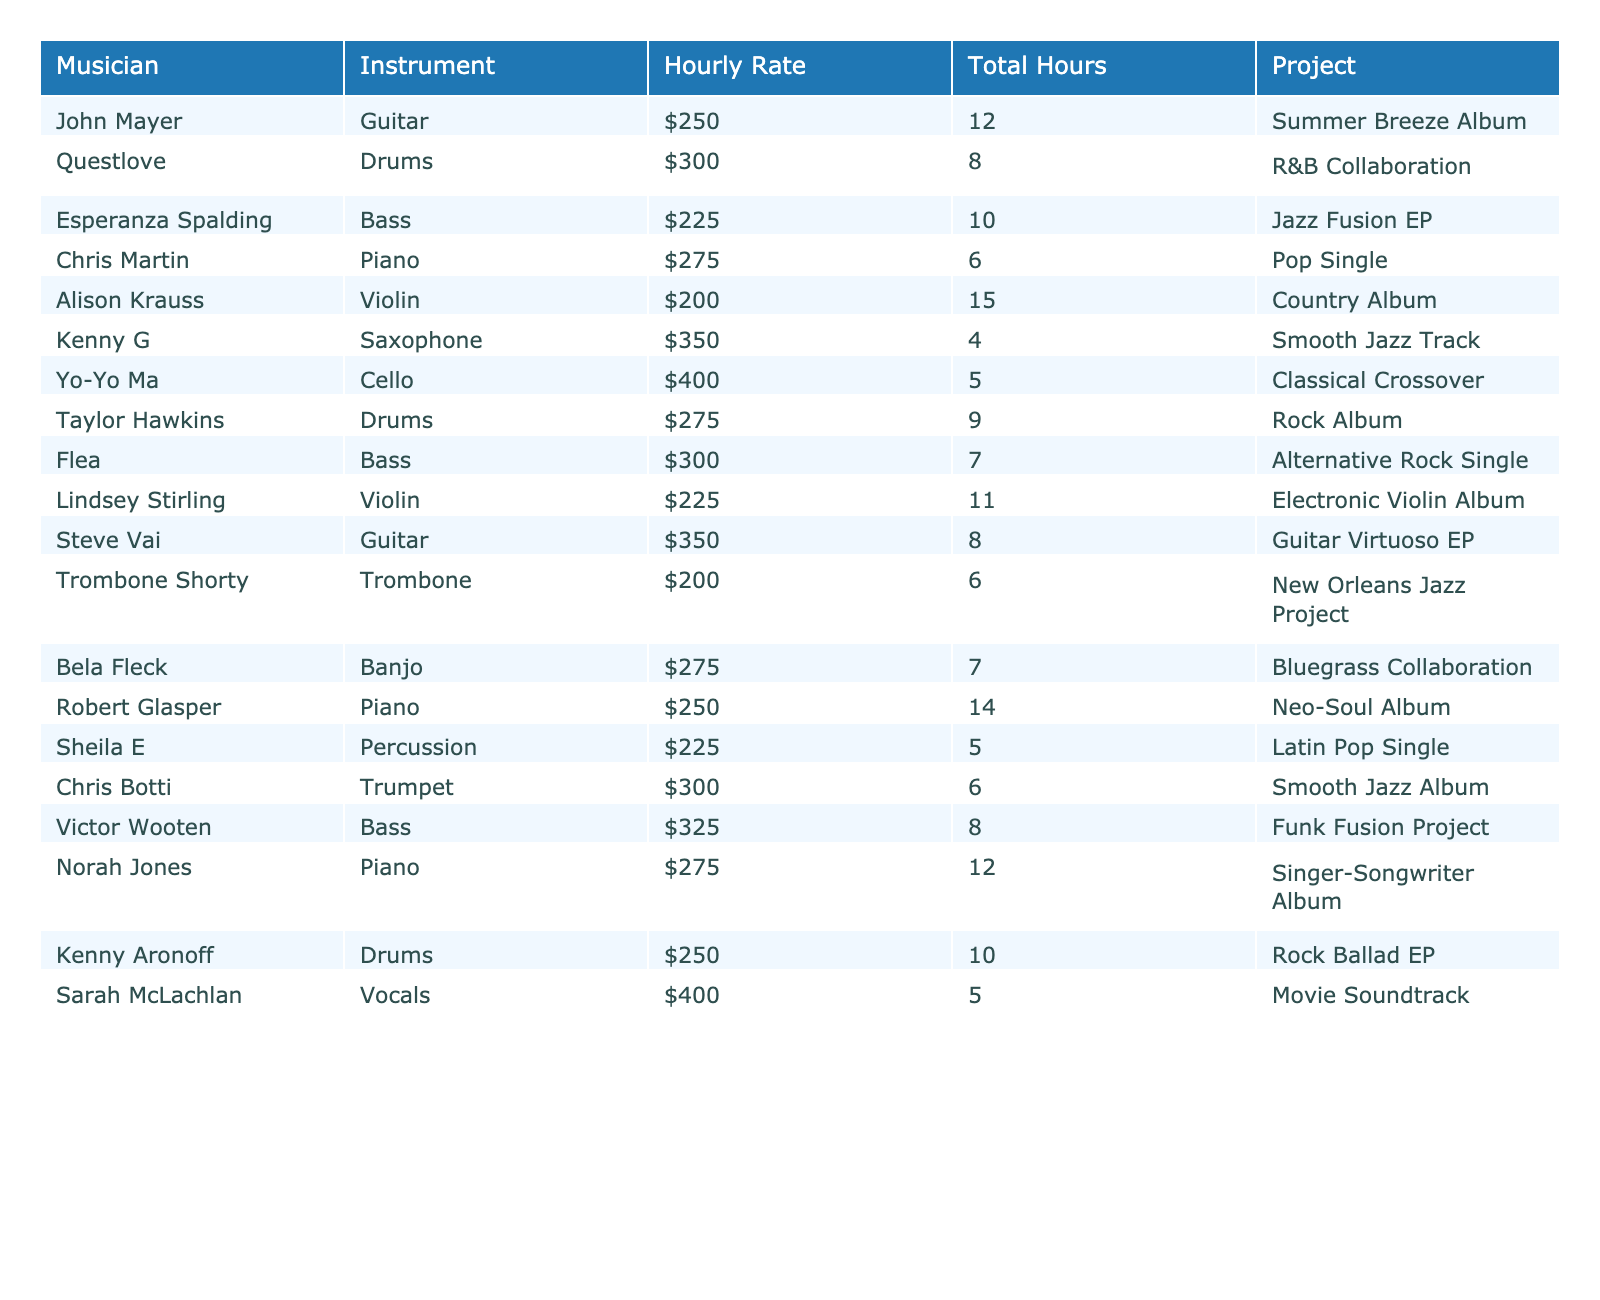What is the highest hourly rate among the musicians? The highest hourly rate is stated directly in the table. By scanning through the "Hourly Rate" column, we notice that Yo-Yo Ma has the highest rate of $400.
Answer: $400 Which musician worked the most hours, and how many hours did they work? To find the musician who worked the most hours, we can look at the "Total Hours" column. Alison Krauss worked the most hours at 15.
Answer: Alison Krauss, 15 hours What is the total cost for hiring Taylor Hawkins, considering their hourly rate and total hours worked? To calculate the total cost, multiply Taylor Hawkins' hourly rate of $275 by his total hours of 9: 275 * 9 = $2,475.
Answer: $2,475 How many musicians played the bass instrument, and what are their names? By reviewing the "Instrument" column, we can count the musicians listed as playing bass. There are three: Esperanza Spalding, Flea, and Victor Wooten.
Answer: 3 musicians: Esperanza Spalding, Flea, Victor Wooten What is the average hourly rate of all musicians listed in the table? First, we sum up all the hourly rates: 250 + 300 + 225 + 275 + 200 + 350 + 400 + 275 + 300 + 225 + 350 + 200 + 275 + 250 + 400 = 3,925. There are 15 musicians, so the average hourly rate is 3,925 divided by 15, which equals approximately $261.67.
Answer: $261.67 Did any musician work fewer than 5 hours? A quick glance at the "Total Hours" column reveals that Kenny G and Sarah McLachlan both worked 4 and 5 hours respectively. This indicates that Kenny G worked fewer than 5 hours.
Answer: Yes, Kenny G worked 4 hours Which project had the lowest hourly rate among the musicians, and what was that rate? By examining the "Hourly Rate" column, we identify the lowest rate: Alison Krauss at $200 for the Country Album project.
Answer: Country Album, $200 Calculate the total hours worked by all the musicians combined. Adding the total hours from the "Total Hours" column: 12 + 8 + 10 + 6 + 15 + 4 + 5 + 9 + 7 + 11 + 8 + 6 + 7 + 14 + 5 =  12 + 8 + 10 + 6 + 15 + 4 + 5 + 9 + 7 + 11 + 8 + 6 + 7 + 14 + 5 = 12 + 8 + 10 + 6 + 15 + 4 + 5 + 9 + 7 + 11 + 8 + 6 + 7 + 14 + 5 = 4 + 10 + 29 + 20 = 138.
Answer: 138 hours Is there any musician who worked on a project that involved both an instrument and vocals? Looking at the table, there is only one musician listed with the "Vocals" instrument, Sarah McLachlan, so her project qualifies as involving both.
Answer: Yes, Sarah McLachlan worked on a project that involved vocals 